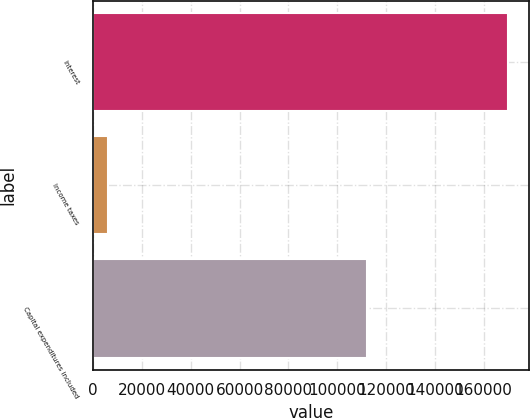Convert chart. <chart><loc_0><loc_0><loc_500><loc_500><bar_chart><fcel>Interest<fcel>Income taxes<fcel>Capital expenditures included<nl><fcel>169987<fcel>6102<fcel>112211<nl></chart> 